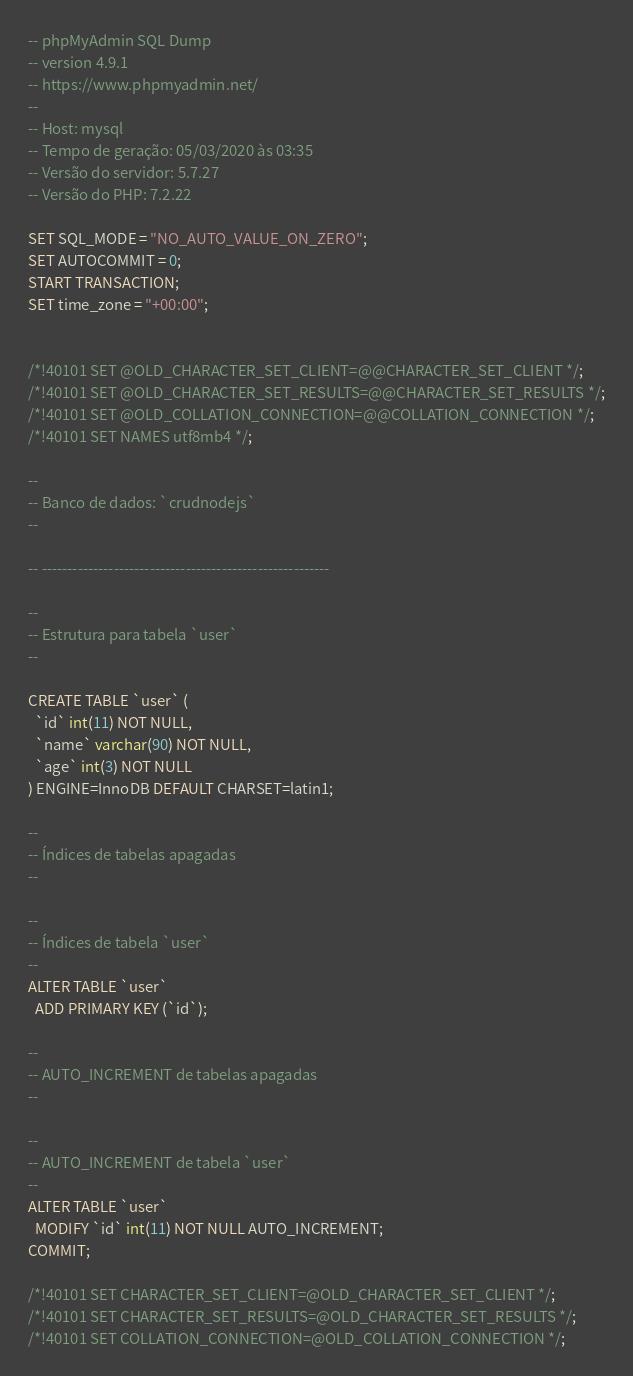Convert code to text. <code><loc_0><loc_0><loc_500><loc_500><_SQL_>-- phpMyAdmin SQL Dump
-- version 4.9.1
-- https://www.phpmyadmin.net/
--
-- Host: mysql
-- Tempo de geração: 05/03/2020 às 03:35
-- Versão do servidor: 5.7.27
-- Versão do PHP: 7.2.22

SET SQL_MODE = "NO_AUTO_VALUE_ON_ZERO";
SET AUTOCOMMIT = 0;
START TRANSACTION;
SET time_zone = "+00:00";


/*!40101 SET @OLD_CHARACTER_SET_CLIENT=@@CHARACTER_SET_CLIENT */;
/*!40101 SET @OLD_CHARACTER_SET_RESULTS=@@CHARACTER_SET_RESULTS */;
/*!40101 SET @OLD_COLLATION_CONNECTION=@@COLLATION_CONNECTION */;
/*!40101 SET NAMES utf8mb4 */;

--
-- Banco de dados: `crudnodejs`
--

-- --------------------------------------------------------

--
-- Estrutura para tabela `user`
--

CREATE TABLE `user` (
  `id` int(11) NOT NULL,
  `name` varchar(90) NOT NULL,
  `age` int(3) NOT NULL
) ENGINE=InnoDB DEFAULT CHARSET=latin1;

--
-- Índices de tabelas apagadas
--

--
-- Índices de tabela `user`
--
ALTER TABLE `user`
  ADD PRIMARY KEY (`id`);

--
-- AUTO_INCREMENT de tabelas apagadas
--

--
-- AUTO_INCREMENT de tabela `user`
--
ALTER TABLE `user`
  MODIFY `id` int(11) NOT NULL AUTO_INCREMENT;
COMMIT;

/*!40101 SET CHARACTER_SET_CLIENT=@OLD_CHARACTER_SET_CLIENT */;
/*!40101 SET CHARACTER_SET_RESULTS=@OLD_CHARACTER_SET_RESULTS */;
/*!40101 SET COLLATION_CONNECTION=@OLD_COLLATION_CONNECTION */;
</code> 